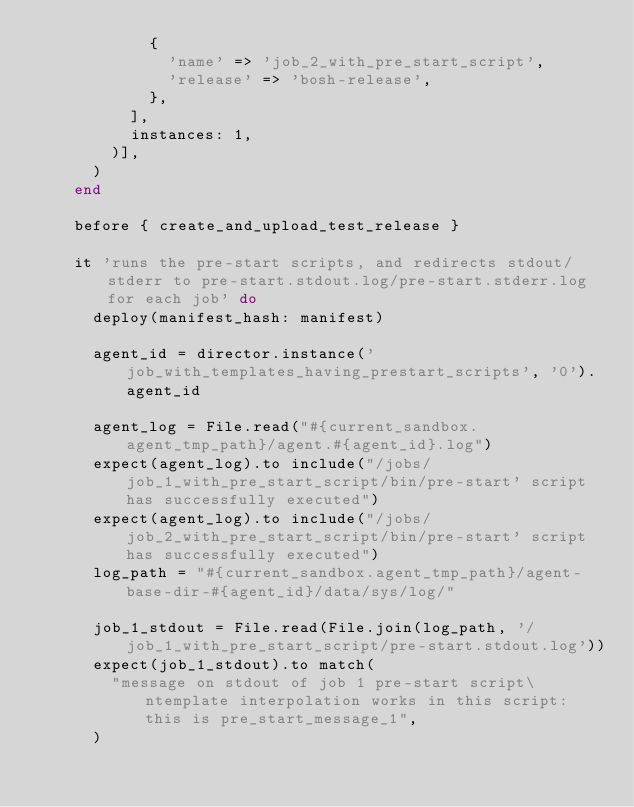Convert code to text. <code><loc_0><loc_0><loc_500><loc_500><_Ruby_>            {
              'name' => 'job_2_with_pre_start_script',
              'release' => 'bosh-release',
            },
          ],
          instances: 1,
        )],
      )
    end

    before { create_and_upload_test_release }

    it 'runs the pre-start scripts, and redirects stdout/stderr to pre-start.stdout.log/pre-start.stderr.log for each job' do
      deploy(manifest_hash: manifest)

      agent_id = director.instance('job_with_templates_having_prestart_scripts', '0').agent_id

      agent_log = File.read("#{current_sandbox.agent_tmp_path}/agent.#{agent_id}.log")
      expect(agent_log).to include("/jobs/job_1_with_pre_start_script/bin/pre-start' script has successfully executed")
      expect(agent_log).to include("/jobs/job_2_with_pre_start_script/bin/pre-start' script has successfully executed")
      log_path = "#{current_sandbox.agent_tmp_path}/agent-base-dir-#{agent_id}/data/sys/log/"

      job_1_stdout = File.read(File.join(log_path, '/job_1_with_pre_start_script/pre-start.stdout.log'))
      expect(job_1_stdout).to match(
        "message on stdout of job 1 pre-start script\ntemplate interpolation works in this script: this is pre_start_message_1",
      )
</code> 